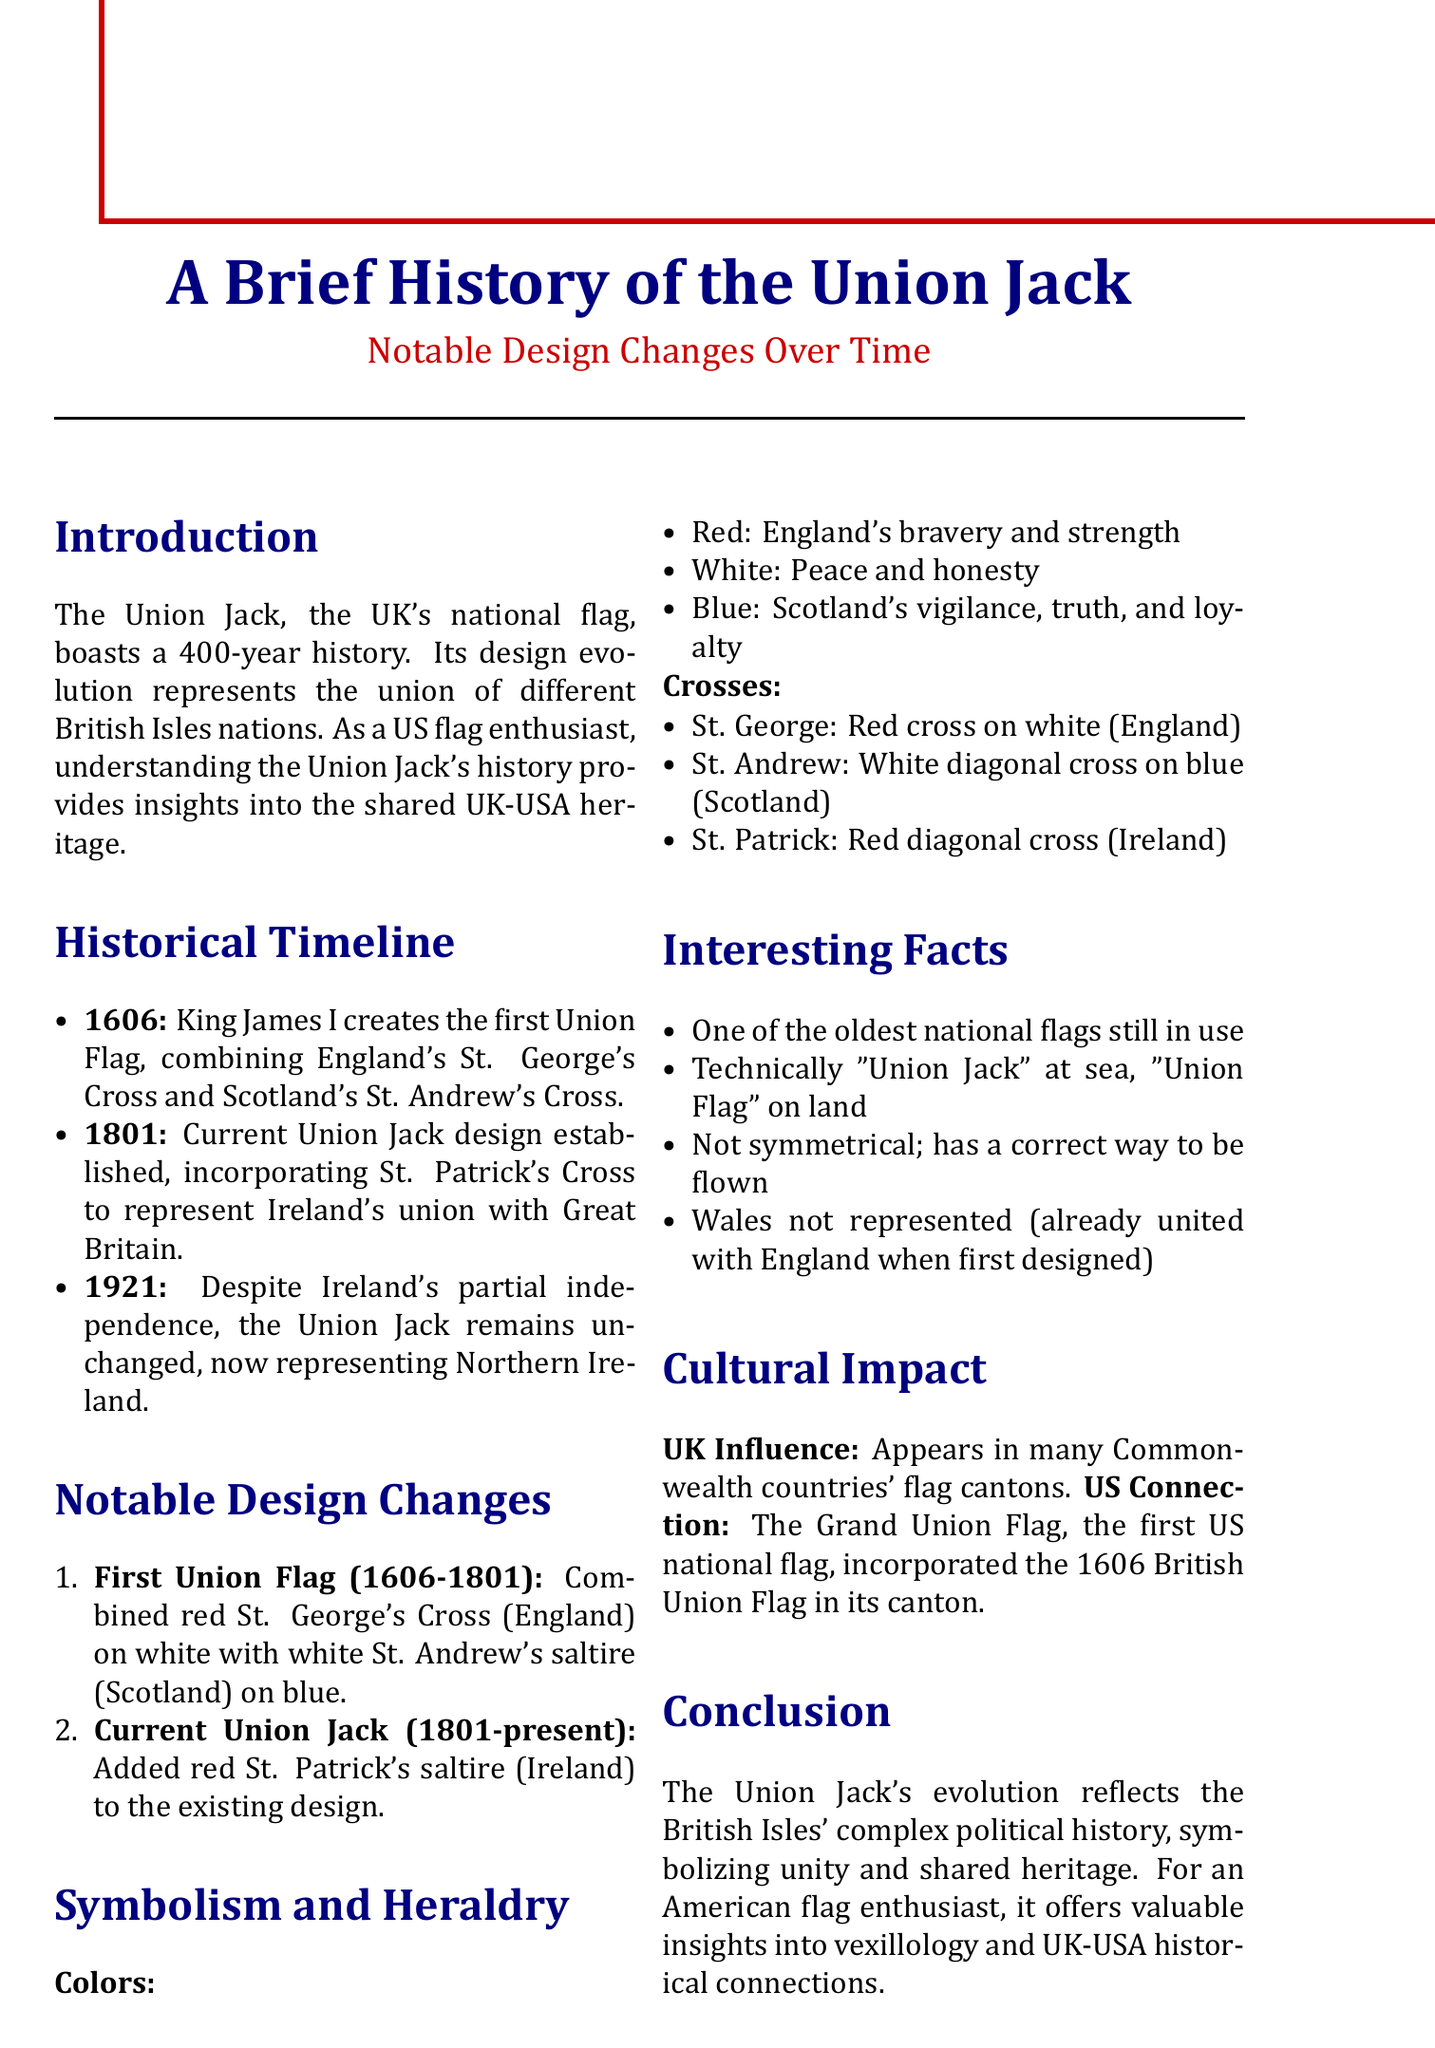What year was the first Union Flag created? The document states that the first Union Flag was created in 1606.
Answer: 1606 What cross was added in 1801? The addition made in 1801 was the cross of St. Patrick.
Answer: St. Patrick's Cross What is the current time range for the Union Jack's design? The document indicates that the current Union Jack has been in use since 1801.
Answer: 1801-present Which nation does the red color represent? The explanation in the document specifies that red represents the bravery and strength of England.
Answer: England What is one interesting fact about the Union Jack? The document lists several facts, one being that it is one of the oldest national flags still in use.
Answer: One of the oldest national flags still in use Why is Wales not represented in the Union Jack? The document explains that Wales is not represented because it was already united with England when the first version was designed.
Answer: United with England What does the white color symbolize? According to the document, white symbolizes peace and honesty.
Answer: Peace and honesty What does the Grand Union Flag represent? The document states that the Grand Union Flag incorporated the British Union Flag of 1606.
Answer: The first national flag of the United States How many years does the Union Jack's history span? The document indicates that the Union Jack has a history spanning over 400 years.
Answer: Over 400 years 